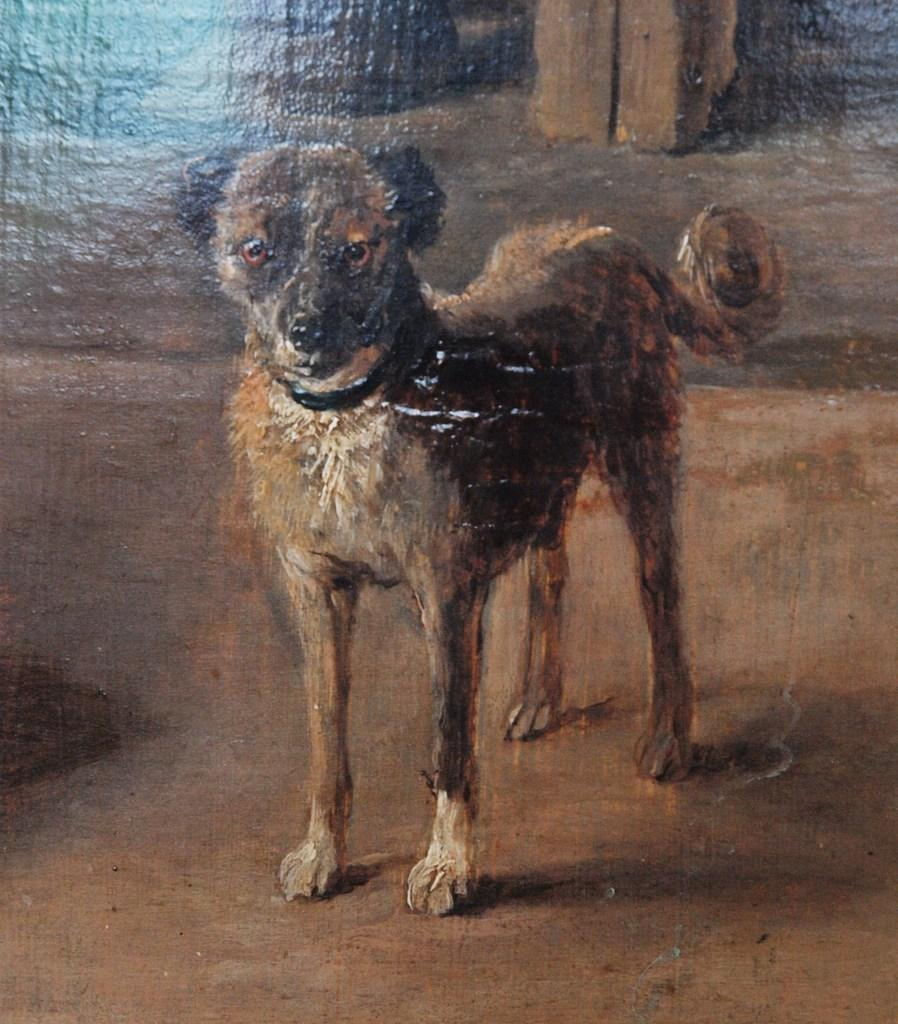What is depicted in the painting in the image? There is a painting of a dog in the image. Can you describe any other objects or features in the image? There is an object in the image, but its specific details are not mentioned. What type of rhythm does the dog have in the painting? The painting is a static image and does not depict any rhythm or movement. 